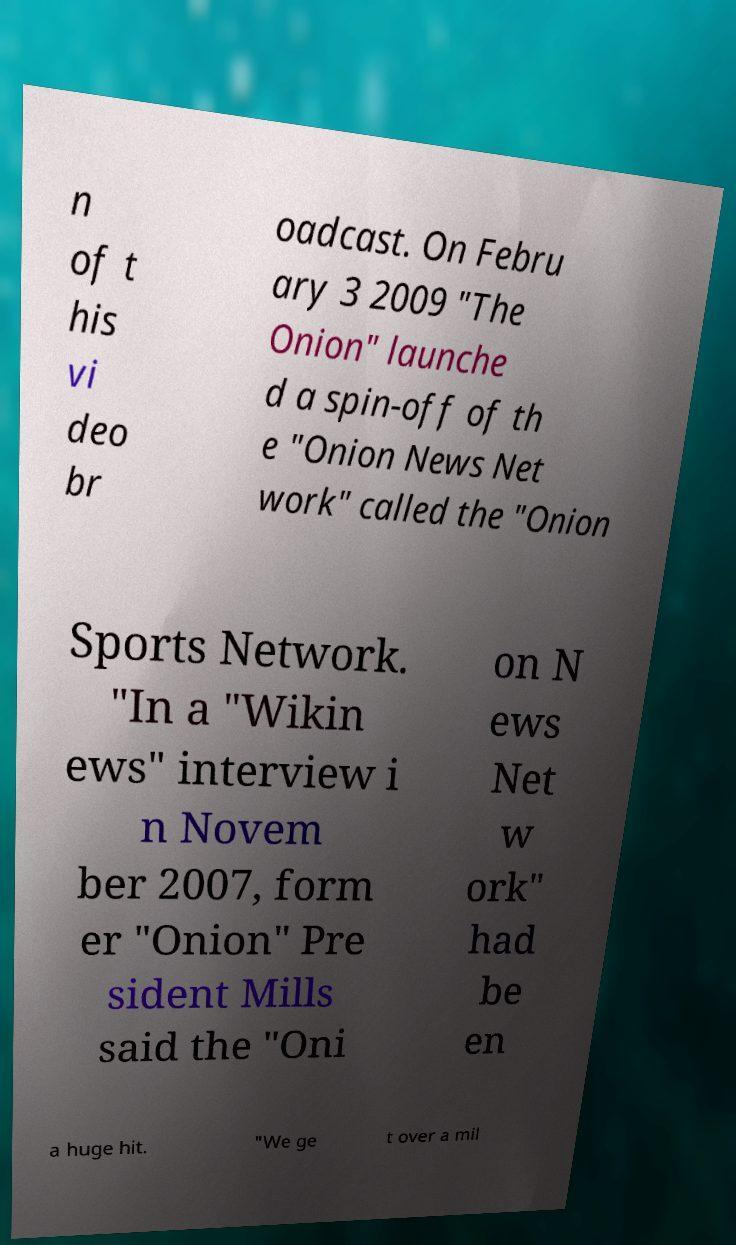Please read and relay the text visible in this image. What does it say? n of t his vi deo br oadcast. On Febru ary 3 2009 "The Onion" launche d a spin-off of th e "Onion News Net work" called the "Onion Sports Network. "In a "Wikin ews" interview i n Novem ber 2007, form er "Onion" Pre sident Mills said the "Oni on N ews Net w ork" had be en a huge hit. "We ge t over a mil 